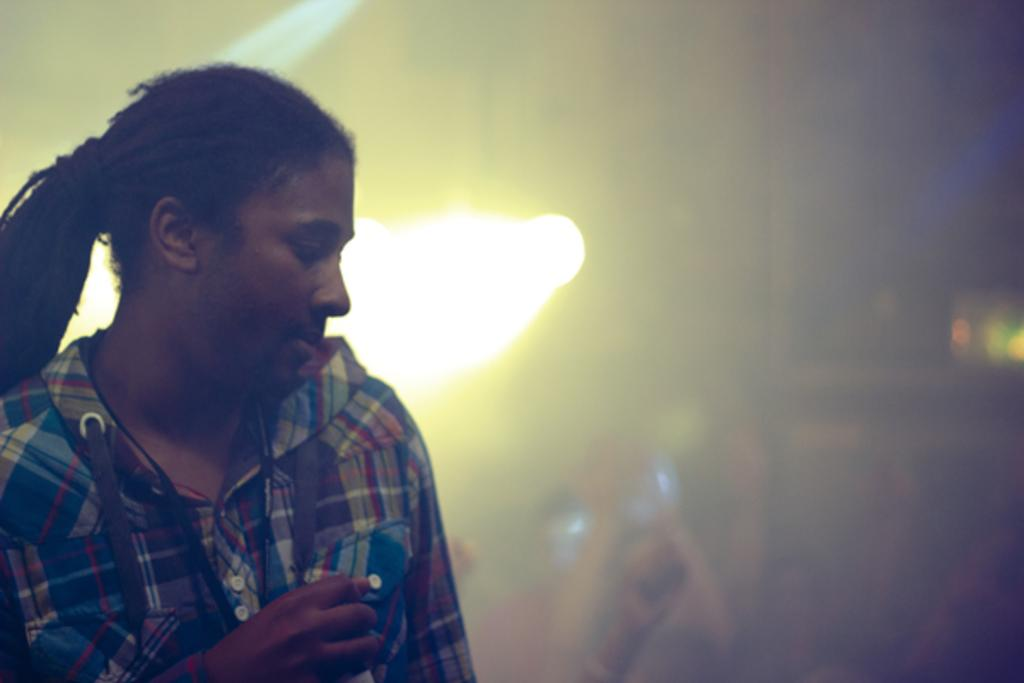What is the main subject of the image? There is a person in the image. What is the person wearing? The person is wearing a shirt. Where is the person located in the image? The person is on the left side of the image. Can you describe the background of the image? The background of the image is blurred, and there is light visible in the background. What type of egg is being used as bait in the image? There is no egg or bait present in the image; it features a person wearing a shirt on the left side of the image with a blurred background. What songs is the person singing in the image? There is no indication in the image that the person is singing any songs. 